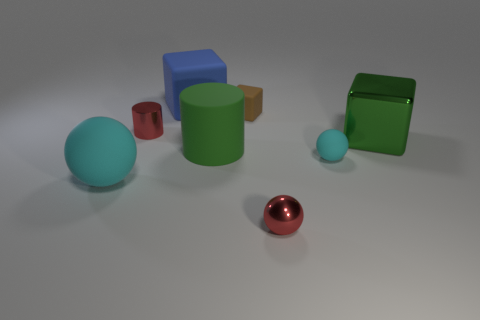The red object left of the small red object that is to the right of the metal cylinder is made of what material? metal 